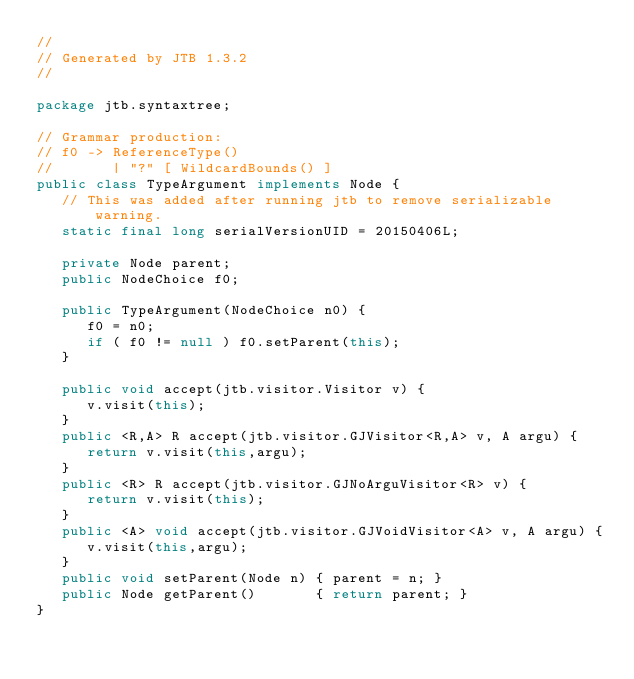Convert code to text. <code><loc_0><loc_0><loc_500><loc_500><_Java_>//
// Generated by JTB 1.3.2
//

package jtb.syntaxtree;

// Grammar production:
// f0 -> ReferenceType()
//       | "?" [ WildcardBounds() ]
public class TypeArgument implements Node {
   // This was added after running jtb to remove serializable warning.
   static final long serialVersionUID = 20150406L;

   private Node parent;
   public NodeChoice f0;

   public TypeArgument(NodeChoice n0) {
      f0 = n0;
      if ( f0 != null ) f0.setParent(this);
   }

   public void accept(jtb.visitor.Visitor v) {
      v.visit(this);
   }
   public <R,A> R accept(jtb.visitor.GJVisitor<R,A> v, A argu) {
      return v.visit(this,argu);
   }
   public <R> R accept(jtb.visitor.GJNoArguVisitor<R> v) {
      return v.visit(this);
   }
   public <A> void accept(jtb.visitor.GJVoidVisitor<A> v, A argu) {
      v.visit(this,argu);
   }
   public void setParent(Node n) { parent = n; }
   public Node getParent()       { return parent; }
}

</code> 